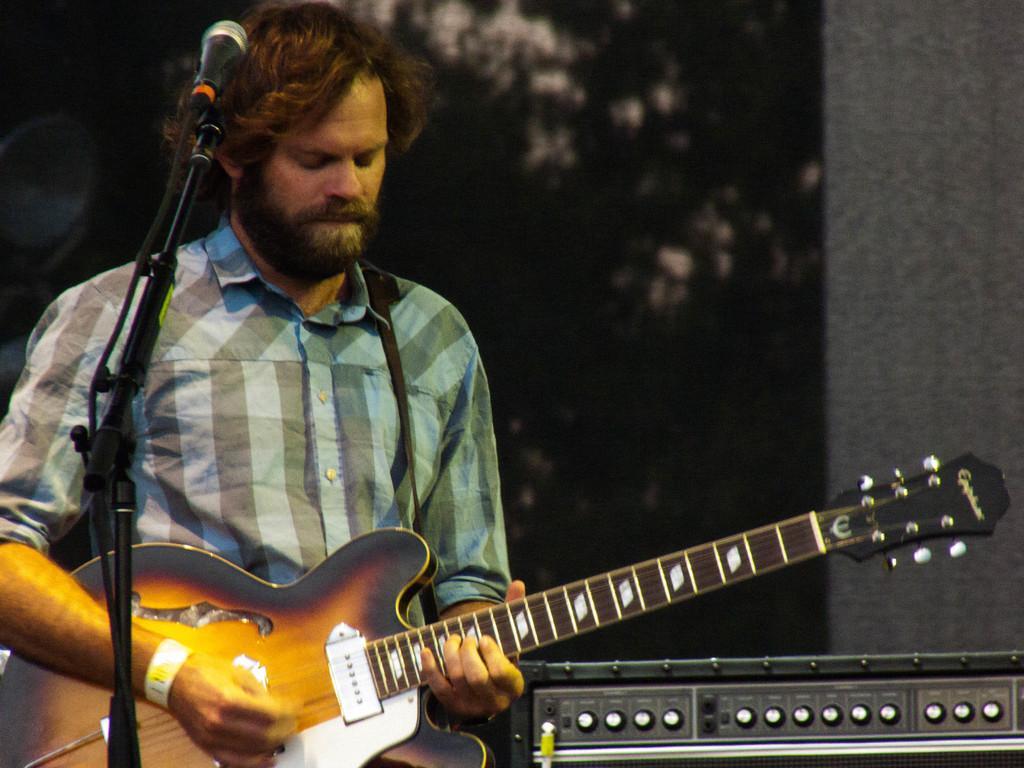Please provide a concise description of this image. In this picture we can see a man who is playing guitar and this is mike. 